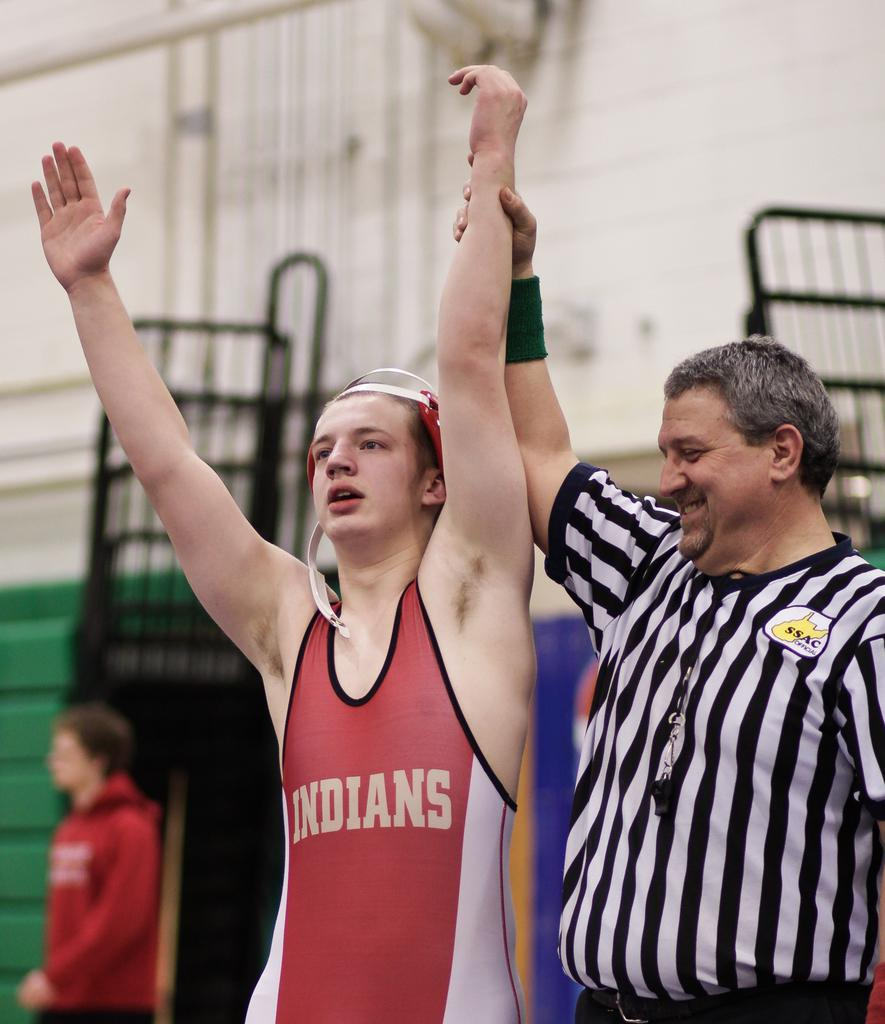<image>
Give a short and clear explanation of the subsequent image. ssac official holds up hand of indians wrestler 